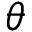<formula> <loc_0><loc_0><loc_500><loc_500>\boldsymbol \theta</formula> 